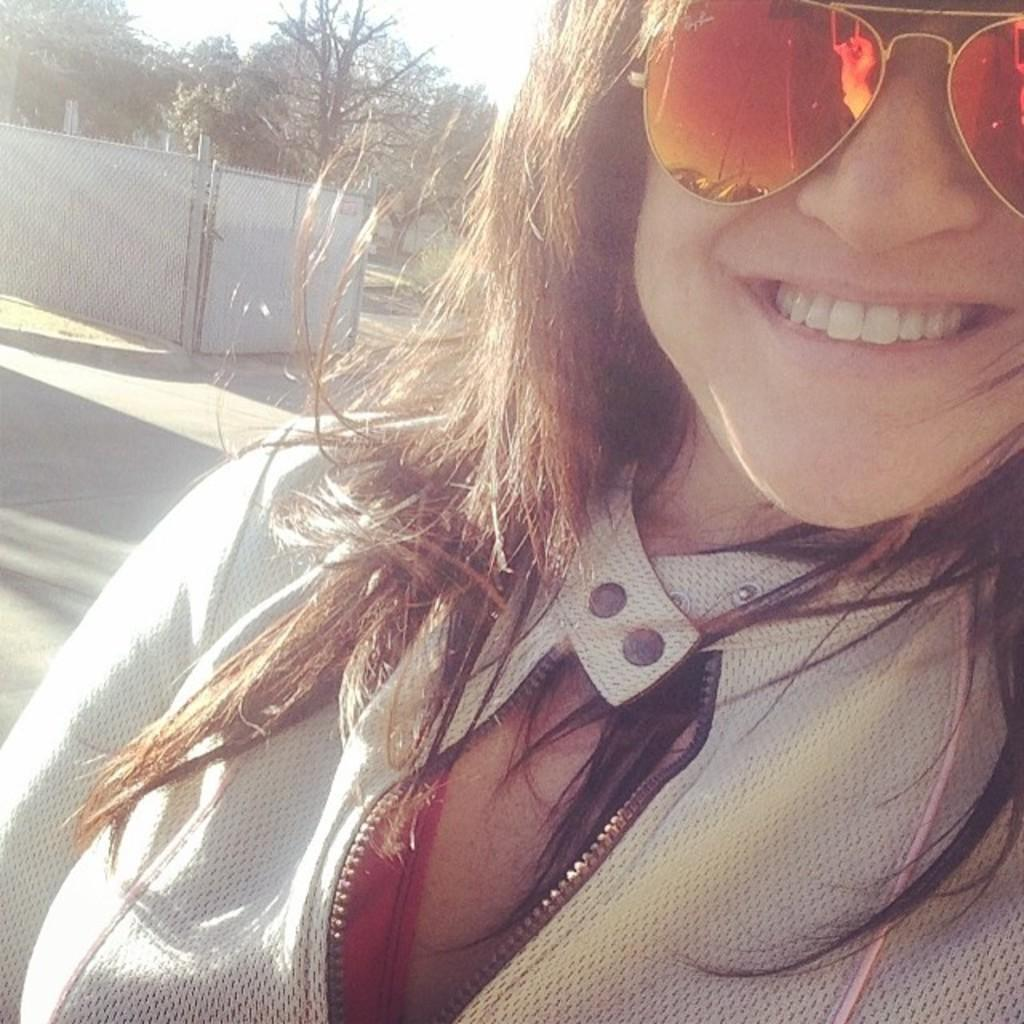Who is present in the image? There is a person in the image. What is the person wearing? The person is wearing a jacket and spectacles. What can be seen in the background of the image? There are trees and a wall in the background of the image. What type of blood is visible on the person's jacket in the image? There is no blood visible on the person's jacket in the image. What kind of lunch is the person eating in the image? There is no lunch present in the image; the person is not eating. 